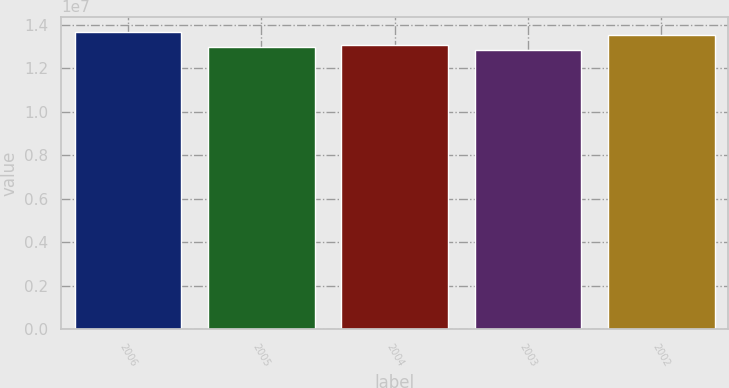<chart> <loc_0><loc_0><loc_500><loc_500><bar_chart><fcel>2006<fcel>2005<fcel>2004<fcel>2003<fcel>2002<nl><fcel>1.3692e+07<fcel>1.2972e+07<fcel>1.30583e+07<fcel>1.2829e+07<fcel>1.3546e+07<nl></chart> 